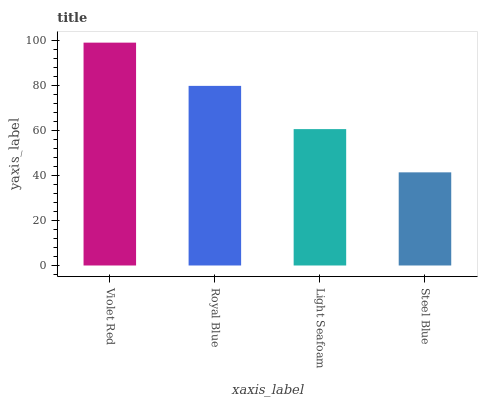Is Steel Blue the minimum?
Answer yes or no. Yes. Is Violet Red the maximum?
Answer yes or no. Yes. Is Royal Blue the minimum?
Answer yes or no. No. Is Royal Blue the maximum?
Answer yes or no. No. Is Violet Red greater than Royal Blue?
Answer yes or no. Yes. Is Royal Blue less than Violet Red?
Answer yes or no. Yes. Is Royal Blue greater than Violet Red?
Answer yes or no. No. Is Violet Red less than Royal Blue?
Answer yes or no. No. Is Royal Blue the high median?
Answer yes or no. Yes. Is Light Seafoam the low median?
Answer yes or no. Yes. Is Light Seafoam the high median?
Answer yes or no. No. Is Royal Blue the low median?
Answer yes or no. No. 